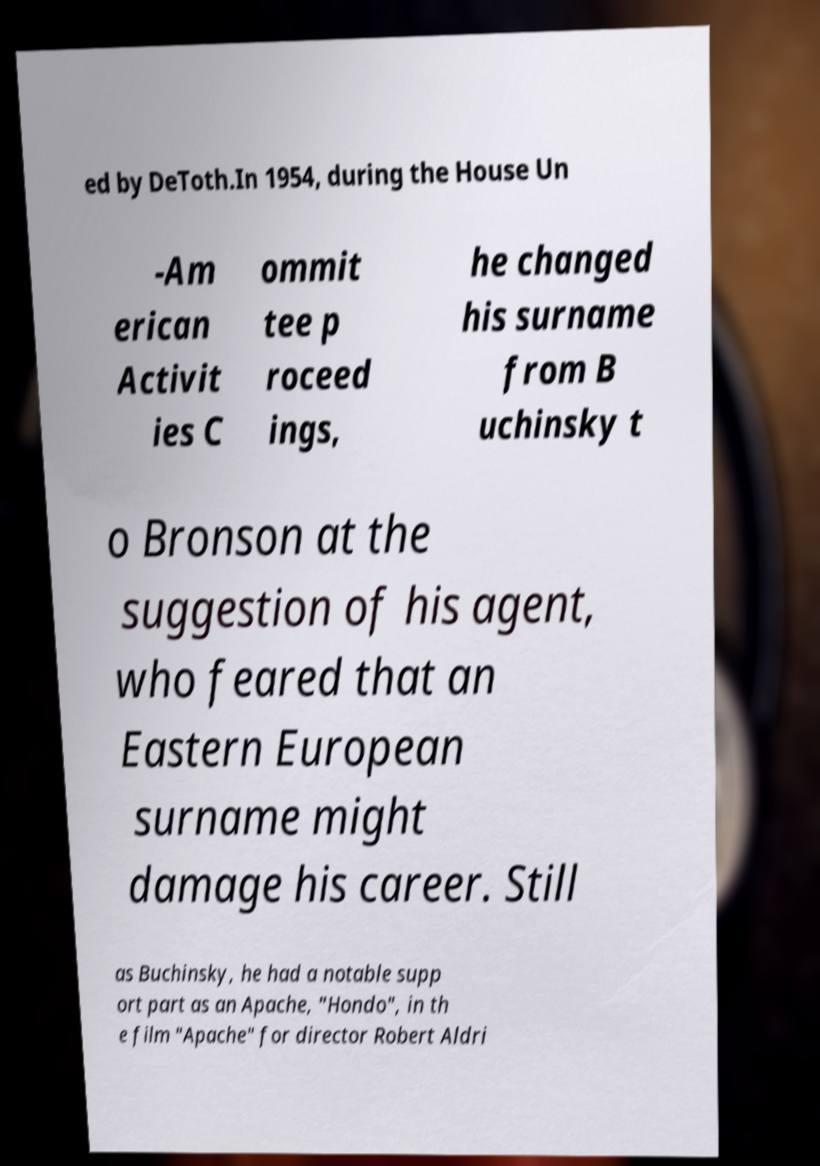Please read and relay the text visible in this image. What does it say? ed by DeToth.In 1954, during the House Un -Am erican Activit ies C ommit tee p roceed ings, he changed his surname from B uchinsky t o Bronson at the suggestion of his agent, who feared that an Eastern European surname might damage his career. Still as Buchinsky, he had a notable supp ort part as an Apache, "Hondo", in th e film "Apache" for director Robert Aldri 